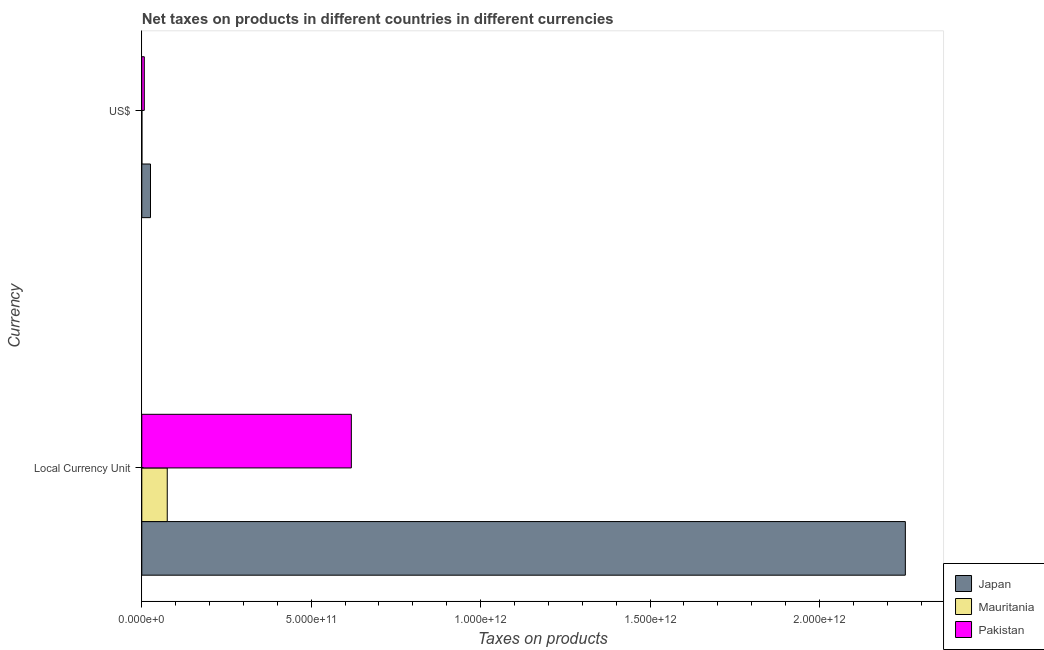How many different coloured bars are there?
Your answer should be compact. 3. How many groups of bars are there?
Offer a very short reply. 2. What is the label of the 2nd group of bars from the top?
Your answer should be very brief. Local Currency Unit. What is the net taxes in constant 2005 us$ in Japan?
Keep it short and to the point. 2.25e+12. Across all countries, what is the maximum net taxes in constant 2005 us$?
Provide a succinct answer. 2.25e+12. Across all countries, what is the minimum net taxes in constant 2005 us$?
Your answer should be compact. 7.51e+1. In which country was the net taxes in us$ minimum?
Your answer should be very brief. Mauritania. What is the total net taxes in constant 2005 us$ in the graph?
Offer a terse response. 2.95e+12. What is the difference between the net taxes in constant 2005 us$ in Japan and that in Pakistan?
Make the answer very short. 1.64e+12. What is the difference between the net taxes in constant 2005 us$ in Pakistan and the net taxes in us$ in Japan?
Provide a succinct answer. 5.93e+11. What is the average net taxes in us$ per country?
Offer a very short reply. 1.11e+1. What is the difference between the net taxes in constant 2005 us$ and net taxes in us$ in Pakistan?
Offer a terse response. 6.11e+11. What is the ratio of the net taxes in constant 2005 us$ in Mauritania to that in Japan?
Offer a very short reply. 0.03. Is the net taxes in constant 2005 us$ in Mauritania less than that in Pakistan?
Offer a very short reply. Yes. In how many countries, is the net taxes in us$ greater than the average net taxes in us$ taken over all countries?
Your answer should be very brief. 1. What does the 1st bar from the top in Local Currency Unit represents?
Give a very brief answer. Pakistan. How many bars are there?
Provide a succinct answer. 6. How many countries are there in the graph?
Keep it short and to the point. 3. What is the difference between two consecutive major ticks on the X-axis?
Provide a succinct answer. 5.00e+11. Does the graph contain any zero values?
Make the answer very short. No. Does the graph contain grids?
Your answer should be compact. No. Where does the legend appear in the graph?
Provide a succinct answer. Bottom right. What is the title of the graph?
Keep it short and to the point. Net taxes on products in different countries in different currencies. Does "Greece" appear as one of the legend labels in the graph?
Keep it short and to the point. No. What is the label or title of the X-axis?
Your answer should be very brief. Taxes on products. What is the label or title of the Y-axis?
Your answer should be very brief. Currency. What is the Taxes on products in Japan in Local Currency Unit?
Your response must be concise. 2.25e+12. What is the Taxes on products of Mauritania in Local Currency Unit?
Offer a terse response. 7.51e+1. What is the Taxes on products in Pakistan in Local Currency Unit?
Your response must be concise. 6.18e+11. What is the Taxes on products of Japan in US$?
Your response must be concise. 2.57e+1. What is the Taxes on products in Mauritania in US$?
Ensure brevity in your answer.  2.72e+08. What is the Taxes on products in Pakistan in US$?
Offer a terse response. 7.38e+09. Across all Currency, what is the maximum Taxes on products in Japan?
Offer a very short reply. 2.25e+12. Across all Currency, what is the maximum Taxes on products in Mauritania?
Your response must be concise. 7.51e+1. Across all Currency, what is the maximum Taxes on products in Pakistan?
Provide a succinct answer. 6.18e+11. Across all Currency, what is the minimum Taxes on products of Japan?
Offer a very short reply. 2.57e+1. Across all Currency, what is the minimum Taxes on products of Mauritania?
Give a very brief answer. 2.72e+08. Across all Currency, what is the minimum Taxes on products of Pakistan?
Your response must be concise. 7.38e+09. What is the total Taxes on products in Japan in the graph?
Provide a succinct answer. 2.28e+12. What is the total Taxes on products of Mauritania in the graph?
Your answer should be compact. 7.54e+1. What is the total Taxes on products of Pakistan in the graph?
Your response must be concise. 6.26e+11. What is the difference between the Taxes on products of Japan in Local Currency Unit and that in US$?
Keep it short and to the point. 2.23e+12. What is the difference between the Taxes on products of Mauritania in Local Currency Unit and that in US$?
Your answer should be very brief. 7.48e+1. What is the difference between the Taxes on products of Pakistan in Local Currency Unit and that in US$?
Provide a succinct answer. 6.11e+11. What is the difference between the Taxes on products of Japan in Local Currency Unit and the Taxes on products of Mauritania in US$?
Provide a short and direct response. 2.25e+12. What is the difference between the Taxes on products in Japan in Local Currency Unit and the Taxes on products in Pakistan in US$?
Offer a very short reply. 2.25e+12. What is the difference between the Taxes on products of Mauritania in Local Currency Unit and the Taxes on products of Pakistan in US$?
Provide a short and direct response. 6.77e+1. What is the average Taxes on products in Japan per Currency?
Your response must be concise. 1.14e+12. What is the average Taxes on products in Mauritania per Currency?
Your answer should be very brief. 3.77e+1. What is the average Taxes on products of Pakistan per Currency?
Keep it short and to the point. 3.13e+11. What is the difference between the Taxes on products in Japan and Taxes on products in Mauritania in Local Currency Unit?
Offer a terse response. 2.18e+12. What is the difference between the Taxes on products of Japan and Taxes on products of Pakistan in Local Currency Unit?
Your answer should be compact. 1.64e+12. What is the difference between the Taxes on products in Mauritania and Taxes on products in Pakistan in Local Currency Unit?
Offer a terse response. -5.43e+11. What is the difference between the Taxes on products in Japan and Taxes on products in Mauritania in US$?
Your response must be concise. 2.54e+1. What is the difference between the Taxes on products of Japan and Taxes on products of Pakistan in US$?
Offer a terse response. 1.83e+1. What is the difference between the Taxes on products in Mauritania and Taxes on products in Pakistan in US$?
Your response must be concise. -7.11e+09. What is the ratio of the Taxes on products in Japan in Local Currency Unit to that in US$?
Your response must be concise. 87.78. What is the ratio of the Taxes on products of Mauritania in Local Currency Unit to that in US$?
Keep it short and to the point. 275.89. What is the ratio of the Taxes on products in Pakistan in Local Currency Unit to that in US$?
Give a very brief answer. 83.8. What is the difference between the highest and the second highest Taxes on products in Japan?
Provide a succinct answer. 2.23e+12. What is the difference between the highest and the second highest Taxes on products of Mauritania?
Offer a terse response. 7.48e+1. What is the difference between the highest and the second highest Taxes on products in Pakistan?
Offer a terse response. 6.11e+11. What is the difference between the highest and the lowest Taxes on products of Japan?
Make the answer very short. 2.23e+12. What is the difference between the highest and the lowest Taxes on products of Mauritania?
Offer a very short reply. 7.48e+1. What is the difference between the highest and the lowest Taxes on products of Pakistan?
Offer a very short reply. 6.11e+11. 